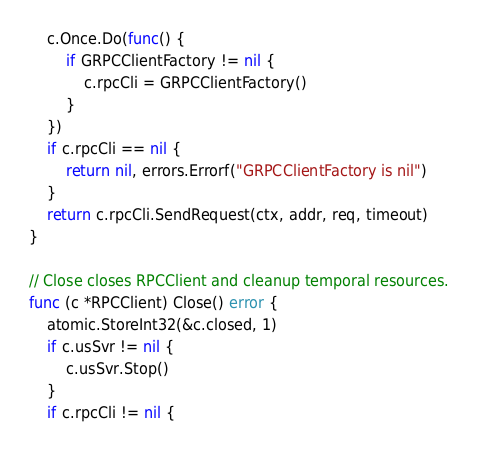<code> <loc_0><loc_0><loc_500><loc_500><_Go_>	c.Once.Do(func() {
		if GRPCClientFactory != nil {
			c.rpcCli = GRPCClientFactory()
		}
	})
	if c.rpcCli == nil {
		return nil, errors.Errorf("GRPCClientFactory is nil")
	}
	return c.rpcCli.SendRequest(ctx, addr, req, timeout)
}

// Close closes RPCClient and cleanup temporal resources.
func (c *RPCClient) Close() error {
	atomic.StoreInt32(&c.closed, 1)
	if c.usSvr != nil {
		c.usSvr.Stop()
	}
	if c.rpcCli != nil {</code> 